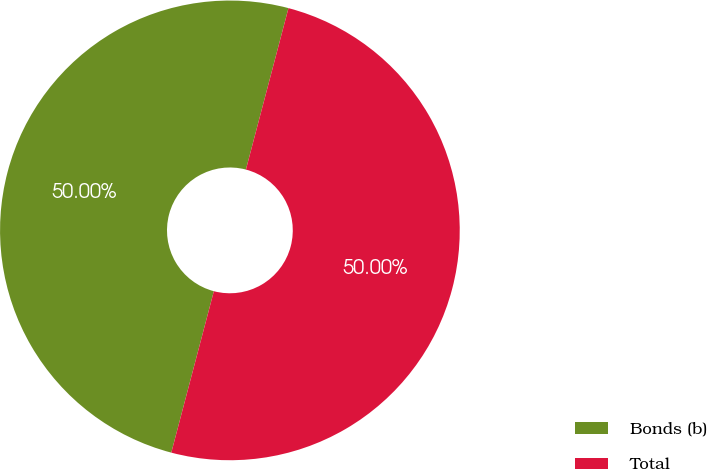Convert chart to OTSL. <chart><loc_0><loc_0><loc_500><loc_500><pie_chart><fcel>Bonds (b)<fcel>Total<nl><fcel>50.0%<fcel>50.0%<nl></chart> 